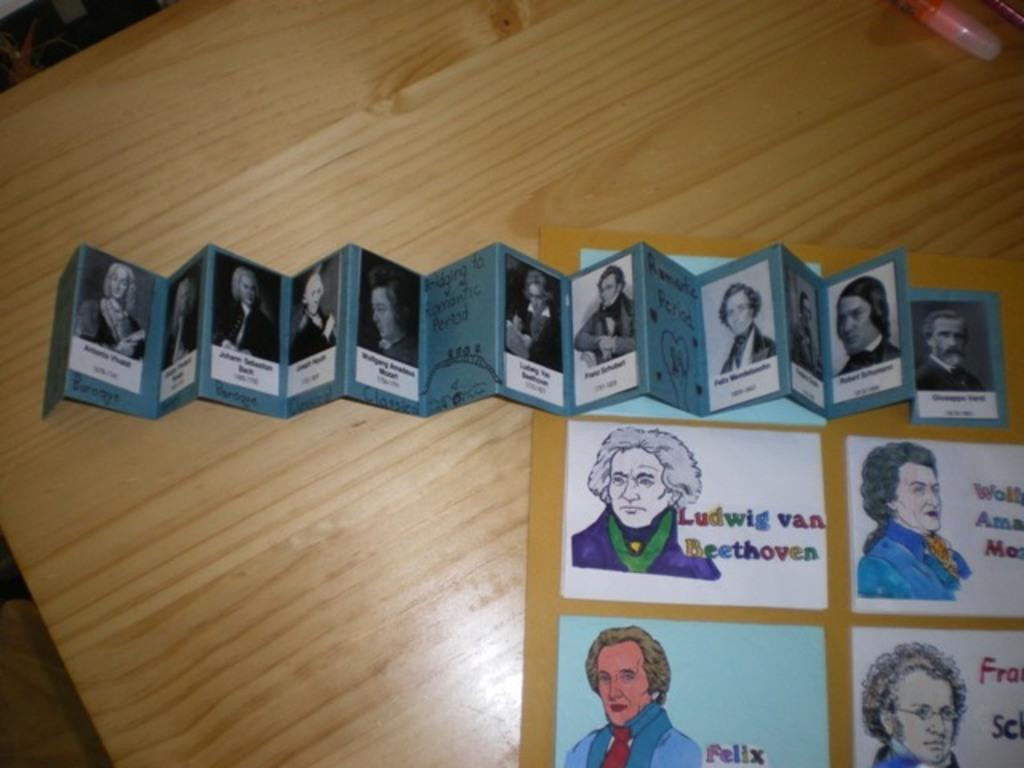What piece of furniture is present in the image? There is a table in the image. What is placed on the table? There are papers and sheets on the table. How many frogs are sitting on the table in the image? There are no frogs present in the image; only papers and sheets are visible on the table. 